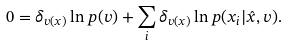<formula> <loc_0><loc_0><loc_500><loc_500>0 = \delta _ { v ( x ) } \ln p ( v ) + \sum _ { i } \delta _ { v ( x ) } \ln p ( x _ { i } | \hat { x } , v ) .</formula> 